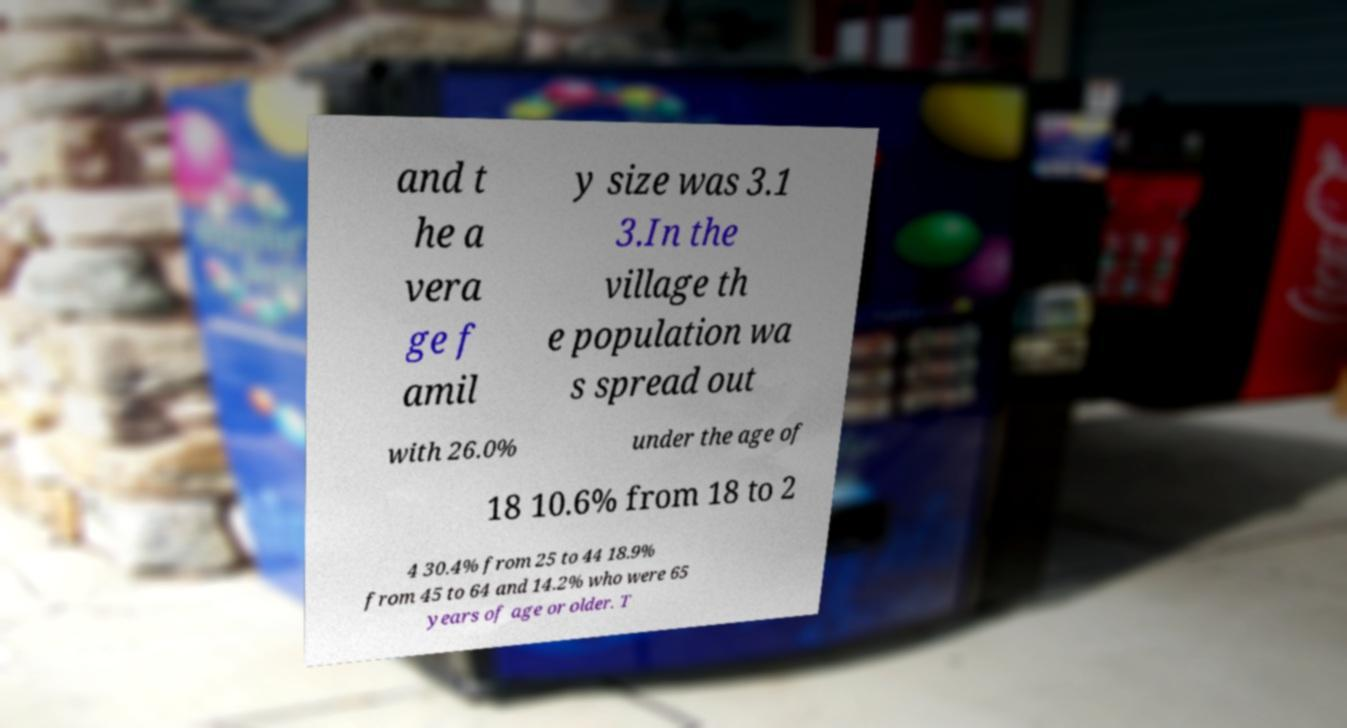Can you accurately transcribe the text from the provided image for me? and t he a vera ge f amil y size was 3.1 3.In the village th e population wa s spread out with 26.0% under the age of 18 10.6% from 18 to 2 4 30.4% from 25 to 44 18.9% from 45 to 64 and 14.2% who were 65 years of age or older. T 